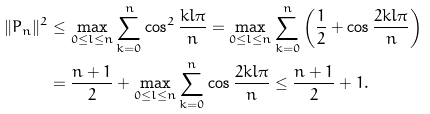<formula> <loc_0><loc_0><loc_500><loc_500>\| P _ { n } \| ^ { 2 } & \leq \max _ { 0 \leq l \leq n } \sum _ { k = 0 } ^ { n } \cos ^ { 2 } \frac { k l \pi } { n } = \max _ { 0 \leq l \leq n } \sum _ { k = 0 } ^ { n } \left ( \frac { 1 } { 2 } + \cos \frac { 2 k l \pi } { n } \right ) \\ & = \frac { n + 1 } { 2 } + \max _ { 0 \leq l \leq n } \sum _ { k = 0 } ^ { n } \cos \frac { 2 k l \pi } { n } \leq \frac { n + 1 } { 2 } + 1 .</formula> 